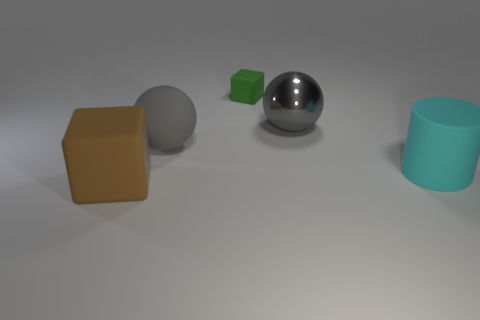There is a block that is right of the brown rubber thing; is it the same size as the cyan matte cylinder?
Keep it short and to the point. No. There is a large rubber object that is the same shape as the tiny rubber thing; what color is it?
Provide a short and direct response. Brown. There is a matte object behind the big gray object that is on the right side of the cube that is on the right side of the brown object; what is its shape?
Provide a short and direct response. Cube. Is the tiny green thing the same shape as the gray matte thing?
Offer a terse response. No. What is the shape of the brown rubber thing on the left side of the cube behind the big cyan thing?
Make the answer very short. Cube. Is there a yellow rubber thing?
Your response must be concise. No. There is a large ball behind the large gray thing that is on the left side of the tiny green cube; what number of brown matte cubes are to the right of it?
Provide a succinct answer. 0. Do the green matte thing and the rubber object that is in front of the large cylinder have the same shape?
Your response must be concise. Yes. Is the number of green matte cubes greater than the number of blue matte things?
Keep it short and to the point. Yes. Is there any other thing that is the same size as the shiny object?
Offer a terse response. Yes. 